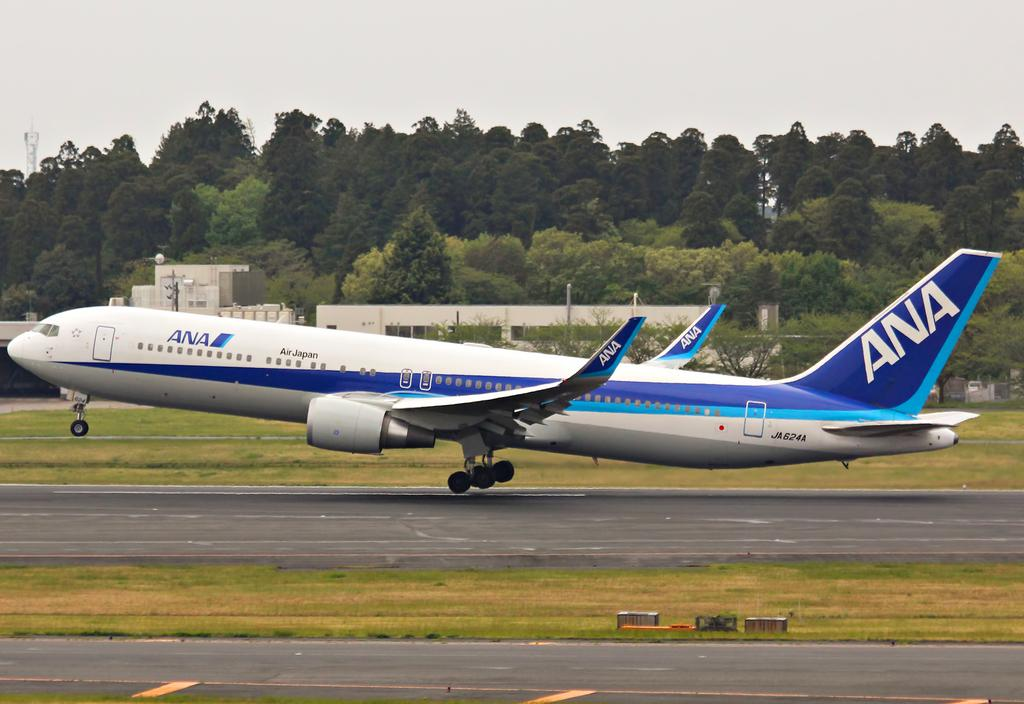What is the main subject in the center of the image? There is an airplane in the center of the image. What can be seen at the bottom of the image? There is a road at the bottom of the image. What type of vegetation is visible in the image? There is grass visible in the image. What is visible in the background of the image? There are trees in the background of the image. What type of disease is affecting the trees in the image? There is no indication of any disease affecting the trees in the image; they appear healthy. What type of brick is used to build the airplane in the image? There is no brick used to build the airplane in the image; it is a metal structure. 